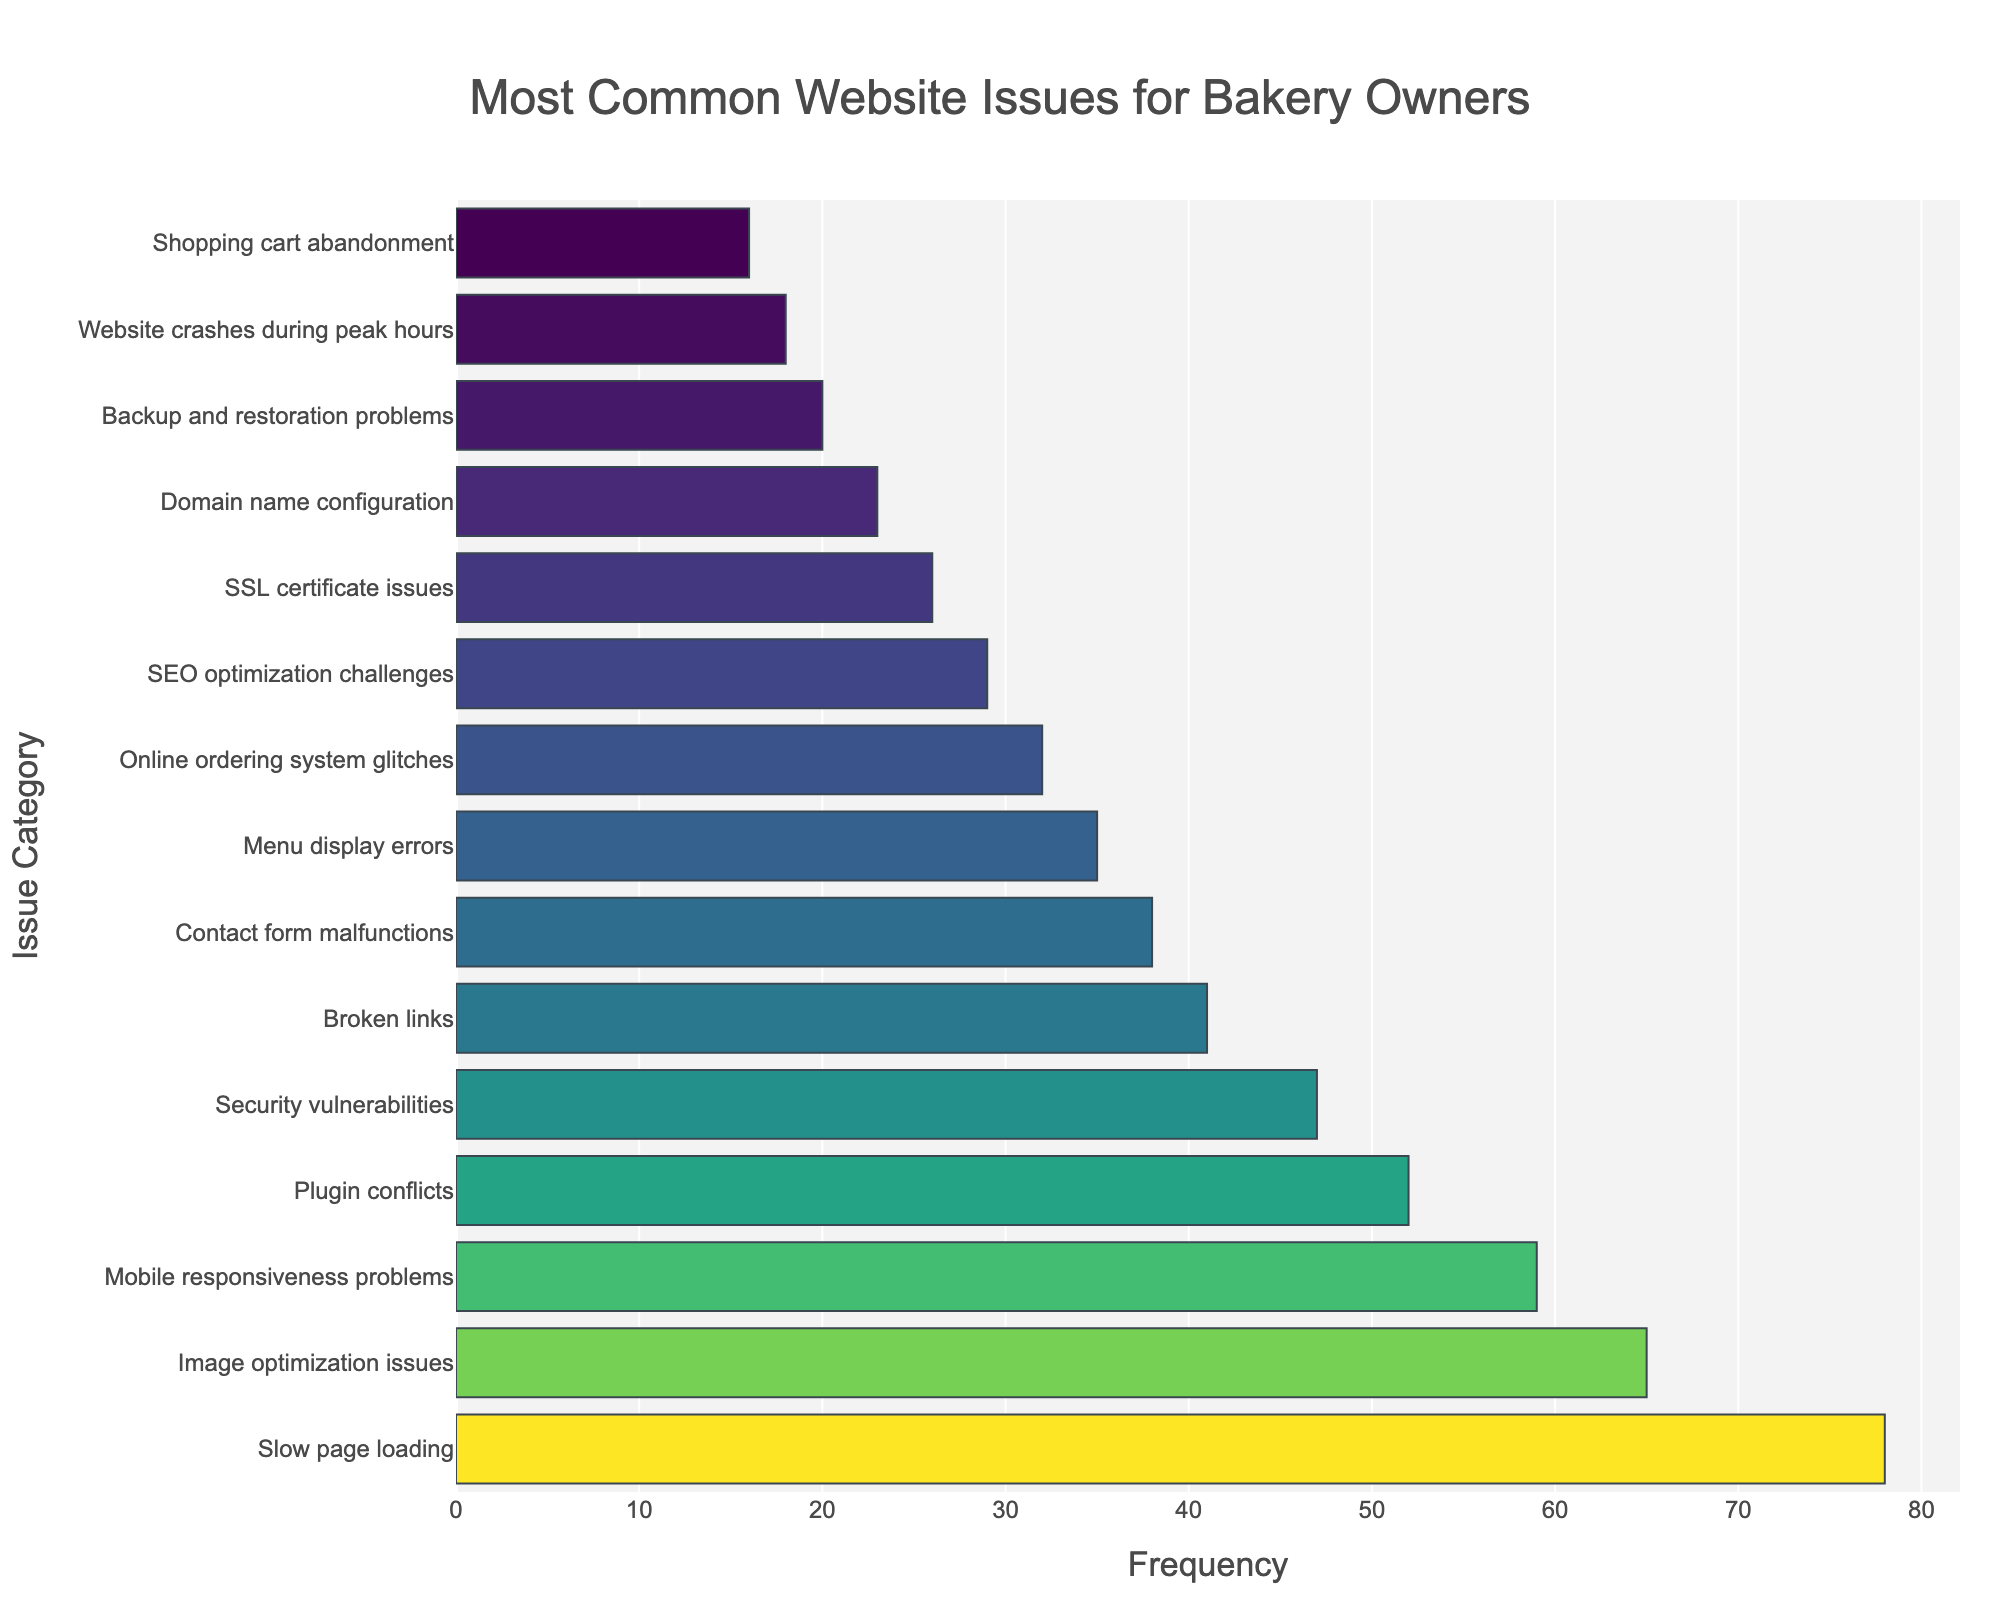Which category has the highest frequency? The highest bar in the chart represents the category with the most occurrences. The category "Slow page loading" stands out as the tallest bar.
Answer: Slow page loading Which two categories have the lowest frequencies? The shortest bars in the chart correspond to the categories with the fewest occurrences. "Shopping cart abandonment" and "Website crashes during peak hours" are the categories with the lowest frequencies.
Answer: Shopping cart abandonment, Website crashes during peak hours How much greater is the frequency of "Slow page loading" compared to "SEO optimization challenges"? First, identify the frequencies: "Slow page loading" has 78 and "SEO optimization challenges" has 29. Subtract the latter from the former: 78 - 29 = 49.
Answer: 49 What is the total frequency of issues related to "Image optimization issues" and "Security vulnerabilities"? Identify the frequencies: "Image optimization issues" has 65 and "Security vulnerabilities" has 47. Add them together: 65 + 47 = 112.
Answer: 112 Which issue category ranks fifth in frequency? The fifth longest bar represents the fifth most common issue. "Plugin conflicts" has the fifth highest frequency in the sorted list.
Answer: Plugin conflicts Which categories have frequencies between 30 and 40? Identify bars with frequencies in this range: "Contact form malfunctions" (38), "Menu display errors" (35), and "Online ordering system glitches" (32).
Answer: Contact form malfunctions, Menu display errors, Online ordering system glitches What is the average frequency of the top three most common issues? The top three frequencies are 78, 65, and 59. Calculate the average: (78 + 65 + 59) / 3 = 67.33.
Answer: 67.33 How many categories have a frequency greater than 50? Count the number of bars with frequencies above 50: "Slow page loading" (78), "Image optimization issues" (65), "Mobile responsiveness problems" (59), and "Plugin conflicts" (52). There are 4 such categories.
Answer: 4 What is the difference in frequency between "SSL certificate issues" and "Backup and restoration problems"? Identify the frequencies: "SSL certificate issues" has 26 and "Backup and restoration problems" has 20. Subtract the latter from the former: 26 - 20 = 6.
Answer: 6 